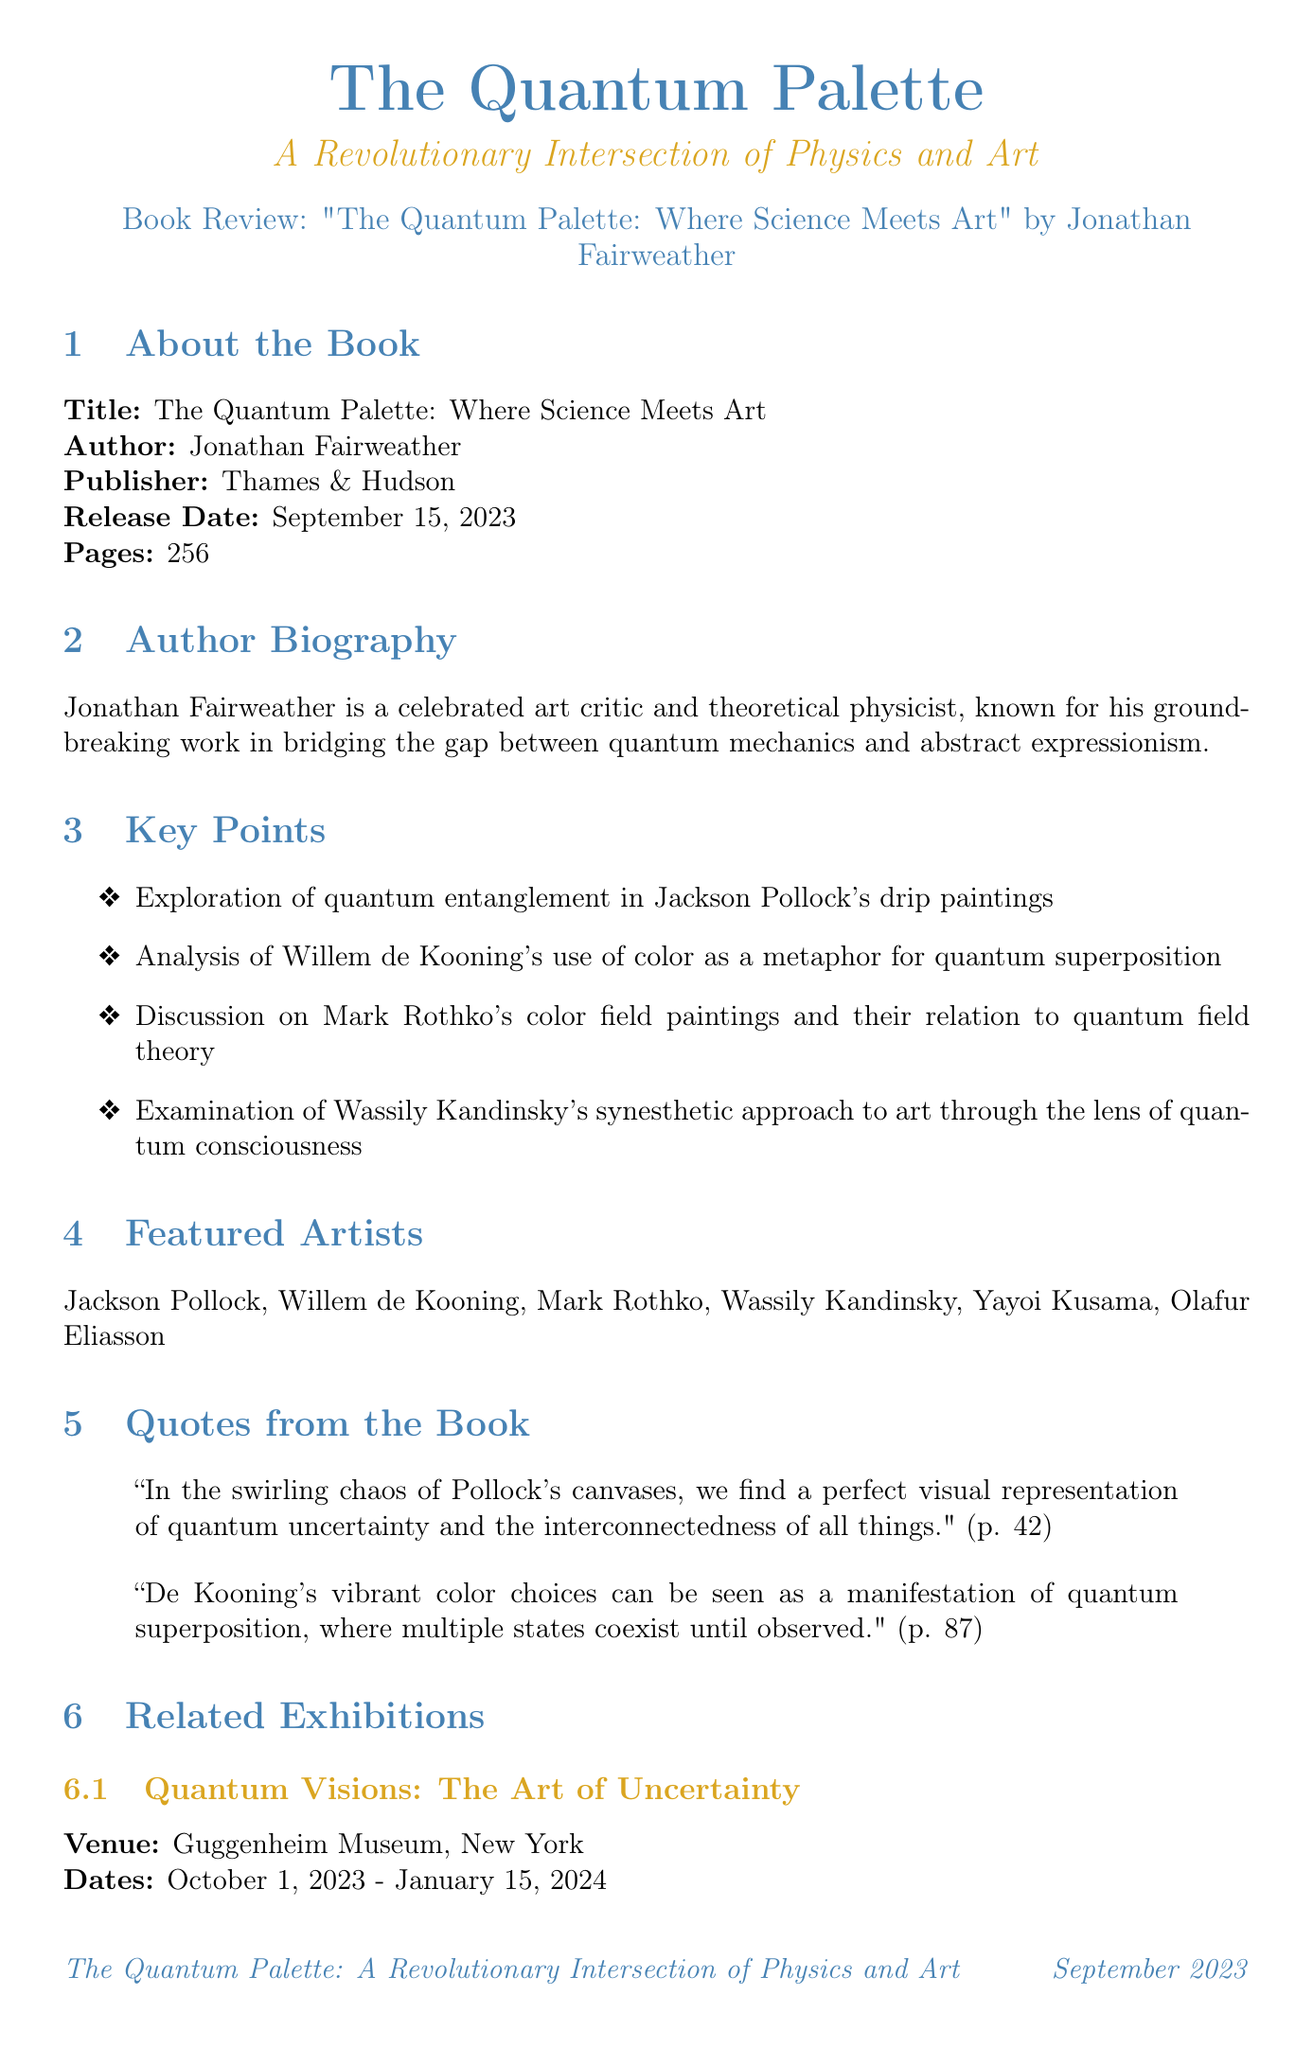What is the title of the book? The title of the book is stated explicitly in the document.
Answer: The Quantum Palette: Where Science Meets Art Who is the author of the book? The author of the book is mentioned in the book details section of the document.
Answer: Jonathan Fairweather When was the book released? The release date of the book is provided under the book details.
Answer: September 15, 2023 How many pages does the book have? The total number of pages is listed in the book details section.
Answer: 256 Which museum is hosting the exhibition "Quantum Visions: The Art of Uncertainty"? The venue for the exhibition is specifically mentioned in the related exhibitions section.
Answer: Guggenheim Museum What concept relates Jackson Pollock's work to quantum physics? The key points include specific concepts that link Pollock's work to quantum physics.
Answer: Quantum entanglement Which artist's work represents quantum infinity? The recommended acquisitions list specifies which artist's work represents this concept.
Answer: Yayoi Kusama What is the date of Jonathan Fairweather's lecture? The date for the lecture is found in the upcoming events section of the document.
Answer: October 12, 2023 Which color theory does Willem de Kooning's work relate to? The key points summarize relations between artists and scientific concepts clearly.
Answer: Quantum superposition 